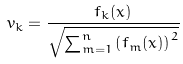<formula> <loc_0><loc_0><loc_500><loc_500>v _ { k } = \frac { f _ { k } ( x ) } { \sqrt { \sum _ { m = 1 } ^ { n } \left ( f _ { m } ( x ) \right ) ^ { 2 } } }</formula> 